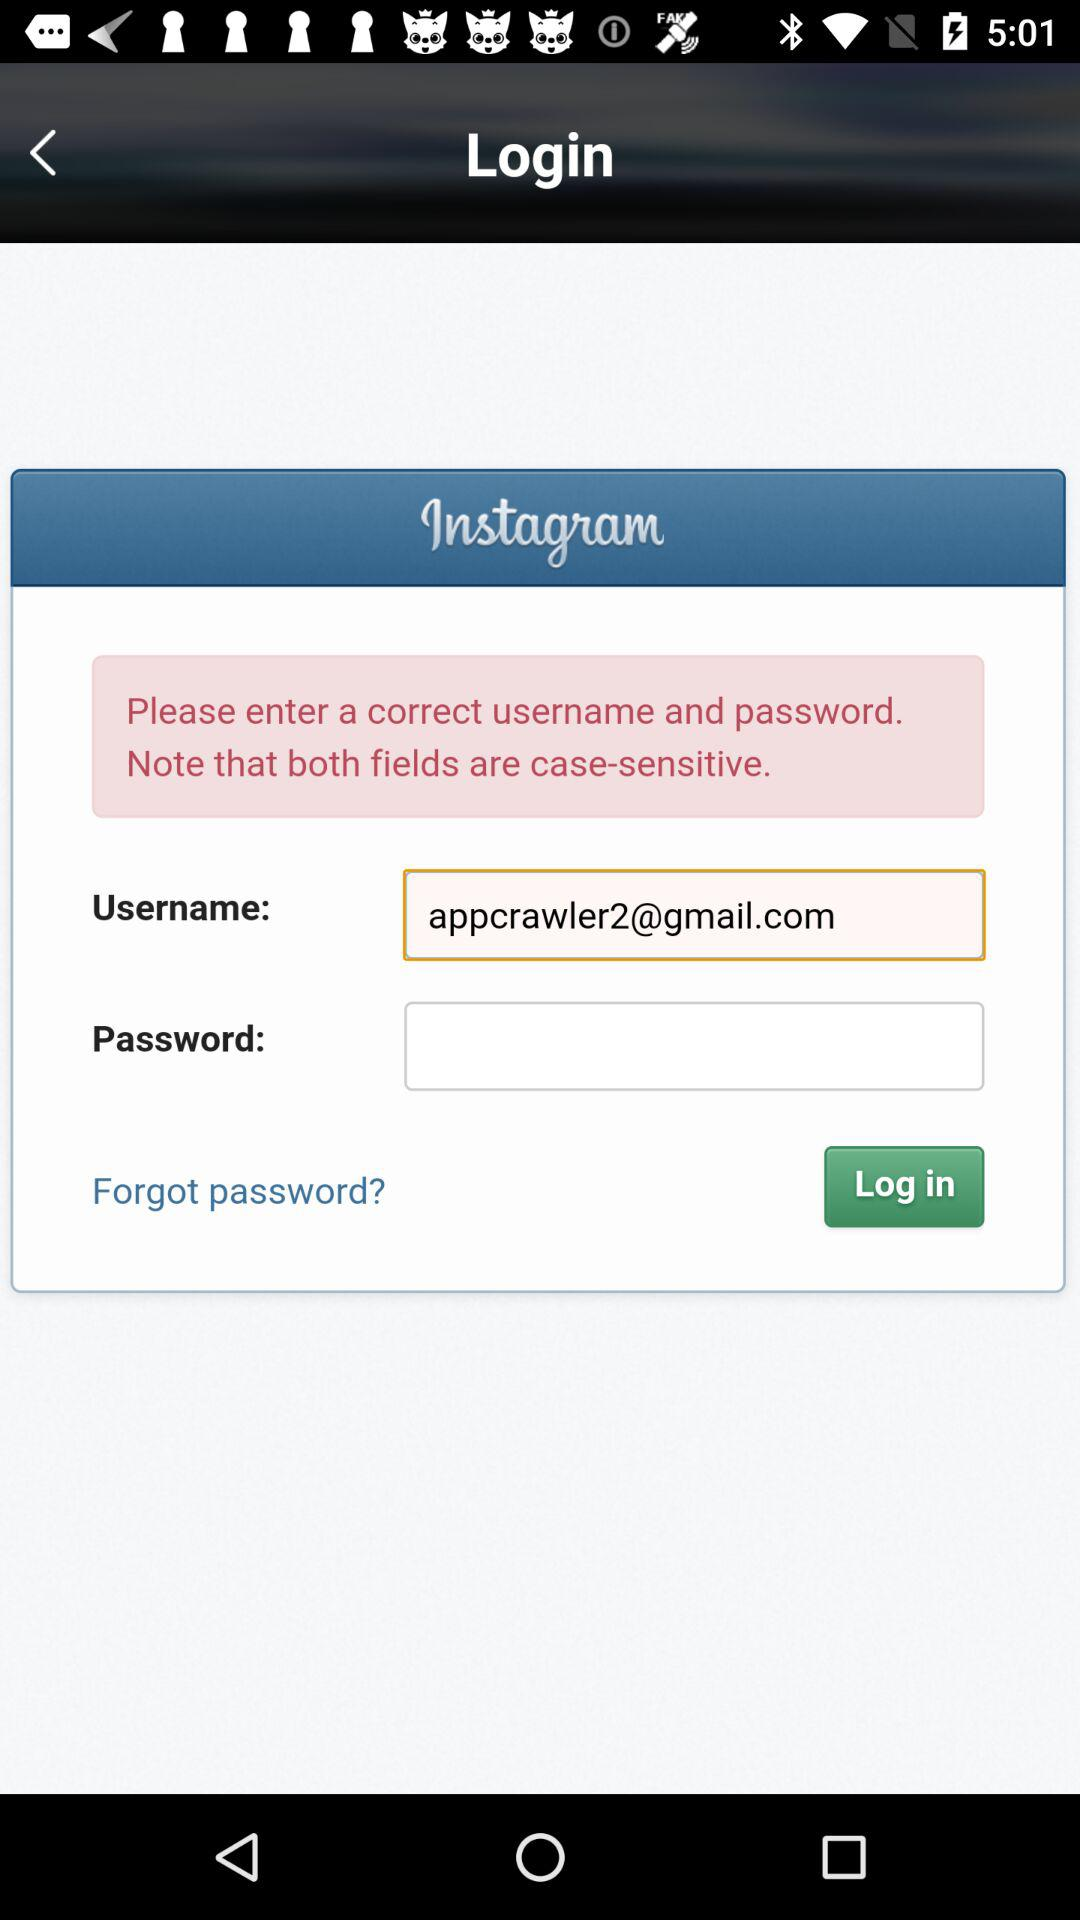What is the username? The username is appcrawler2@gmail.com. 